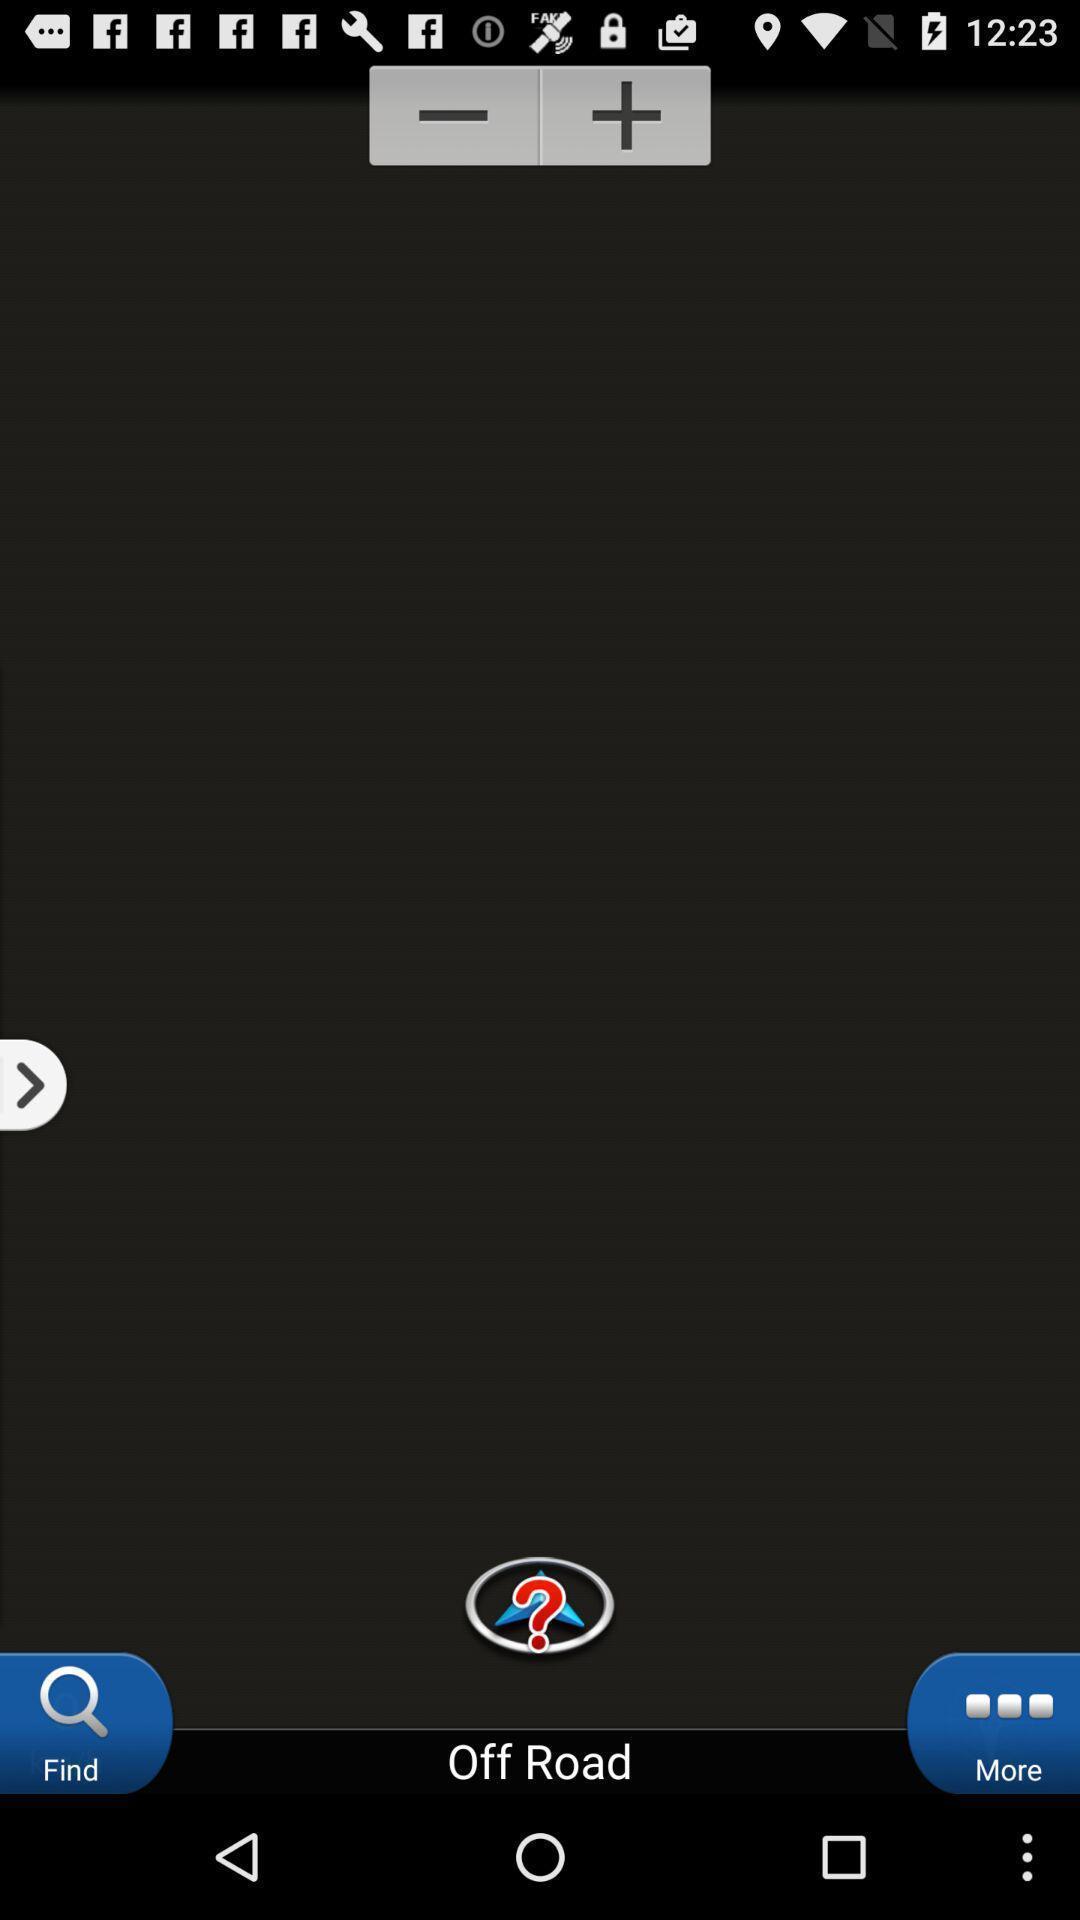Tell me about the visual elements in this screen capture. Screen displaying the options in maps for directions. 